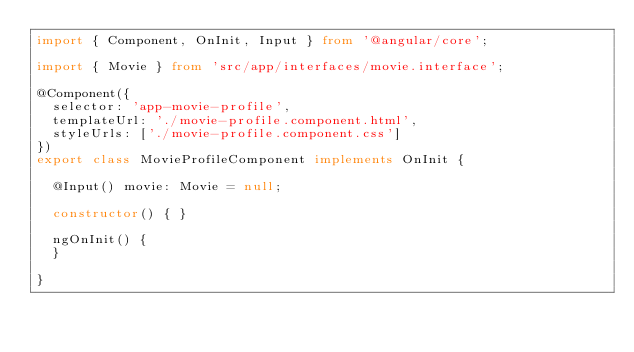<code> <loc_0><loc_0><loc_500><loc_500><_TypeScript_>import { Component, OnInit, Input } from '@angular/core';

import { Movie } from 'src/app/interfaces/movie.interface';

@Component({
  selector: 'app-movie-profile',
  templateUrl: './movie-profile.component.html',
  styleUrls: ['./movie-profile.component.css']
})
export class MovieProfileComponent implements OnInit {

  @Input() movie: Movie = null;

  constructor() { }

  ngOnInit() {
  }

}
</code> 